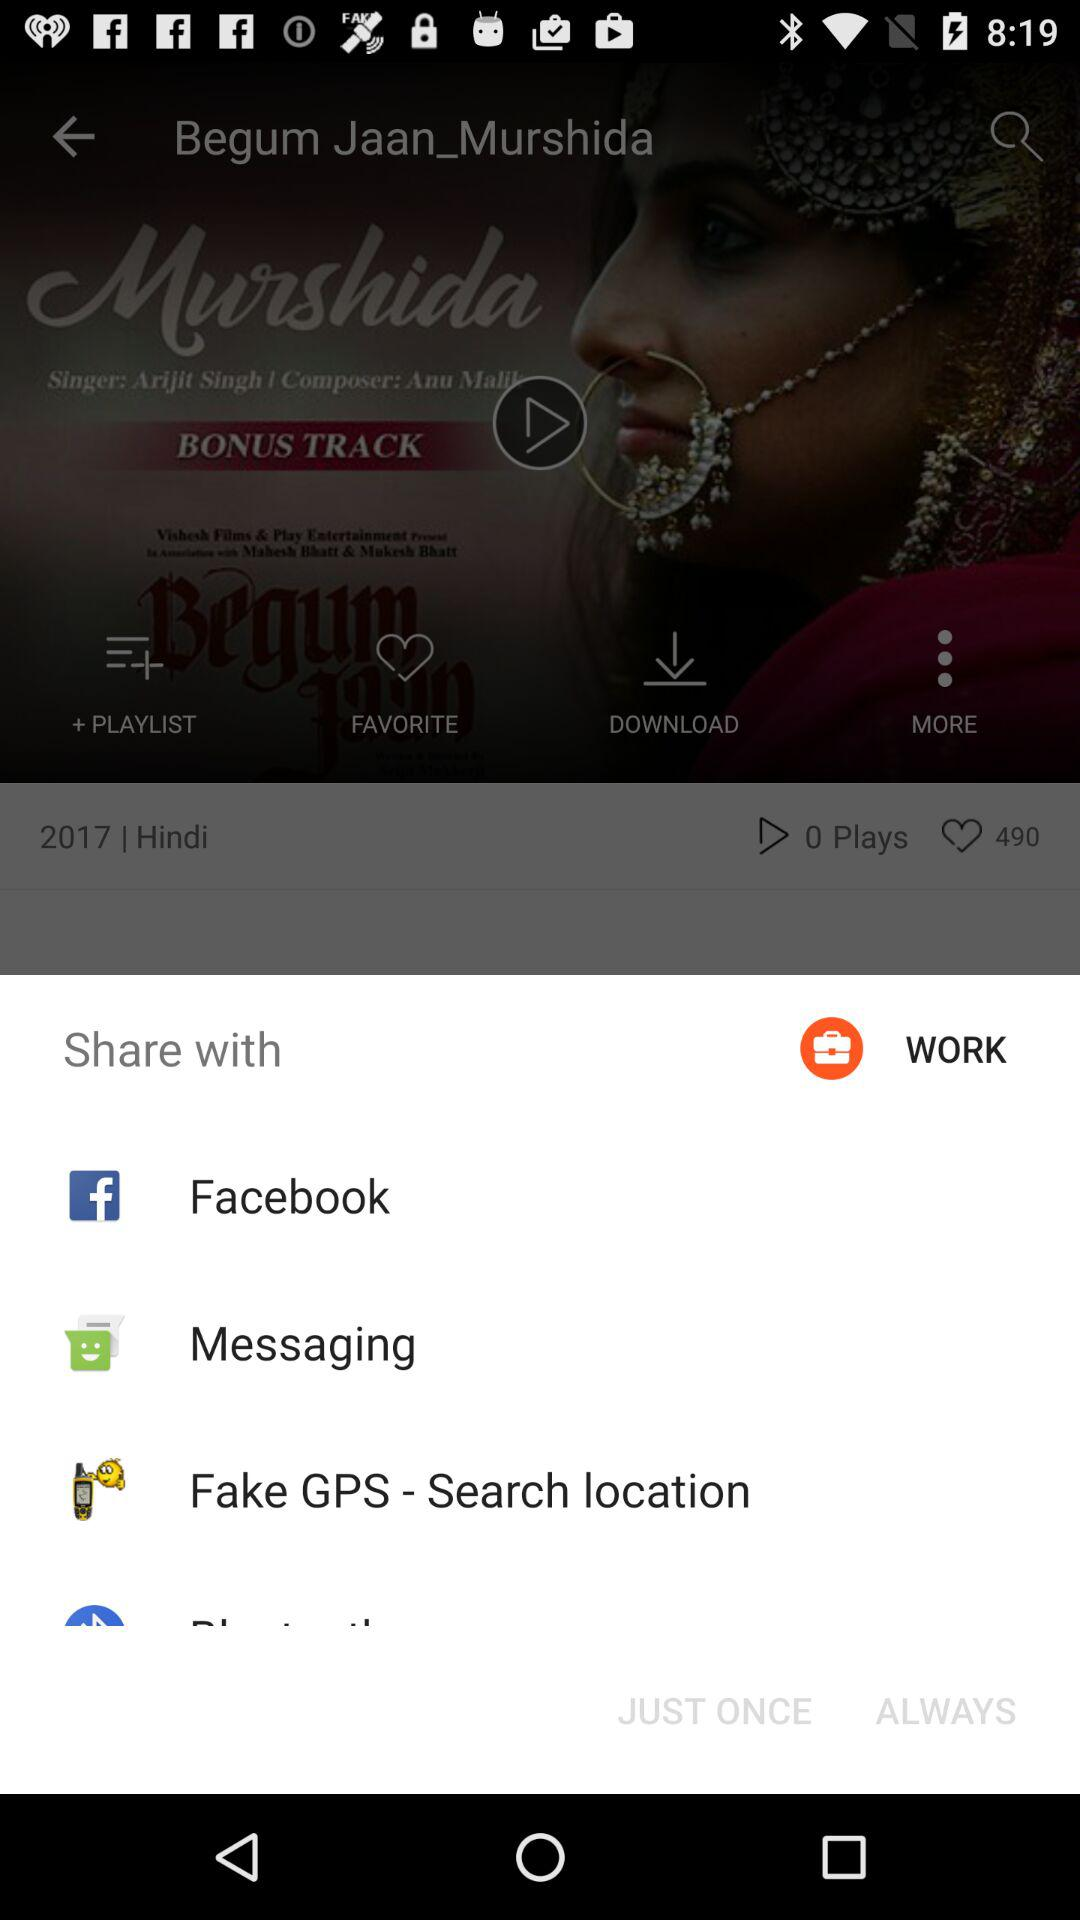What app can I use to share? You can use "Facebook", "Messaging" and "Fake GPS - Search location" to share. 